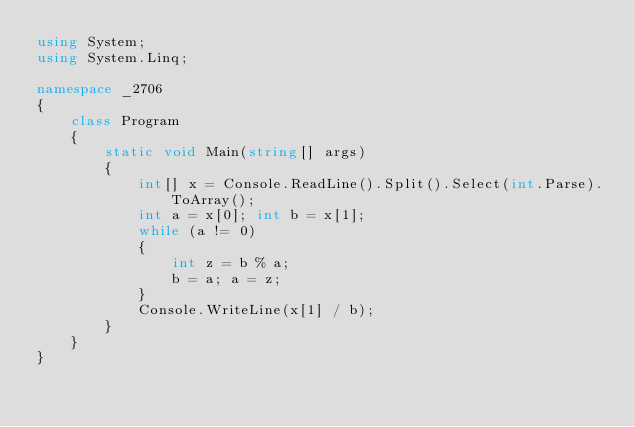<code> <loc_0><loc_0><loc_500><loc_500><_C#_>using System;
using System.Linq;

namespace _2706
{
    class Program
    {
        static void Main(string[] args)
        {
            int[] x = Console.ReadLine().Split().Select(int.Parse).ToArray();
            int a = x[0]; int b = x[1];
            while (a != 0)
            {
                int z = b % a;
                b = a; a = z;
            }
            Console.WriteLine(x[1] / b);
        }
    }
}</code> 